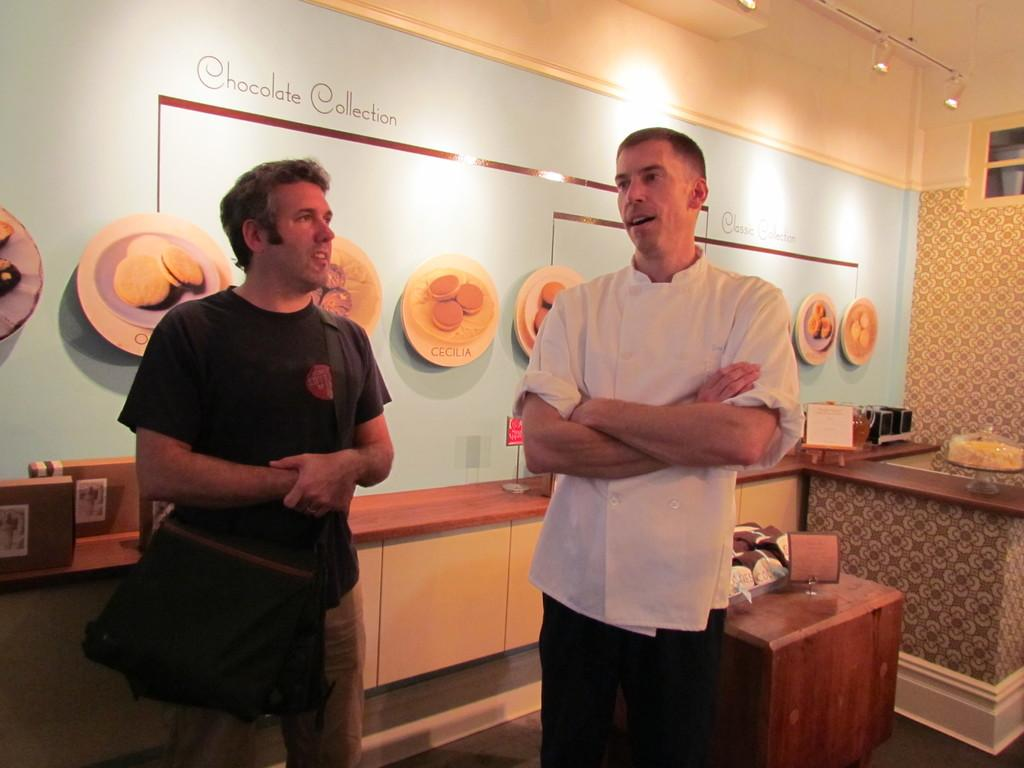How many people are present in the image? There are two men in the image. What can be seen in the background of the image? There are unspecified objects in the background of the image. What is one feature of the setting in the image? There is a wall in the image. What is another feature of the setting in the image? There are lights in the image. What is the rate of the van's speed in the image? There is no van present in the image, so it is not possible to determine its speed or rate. 